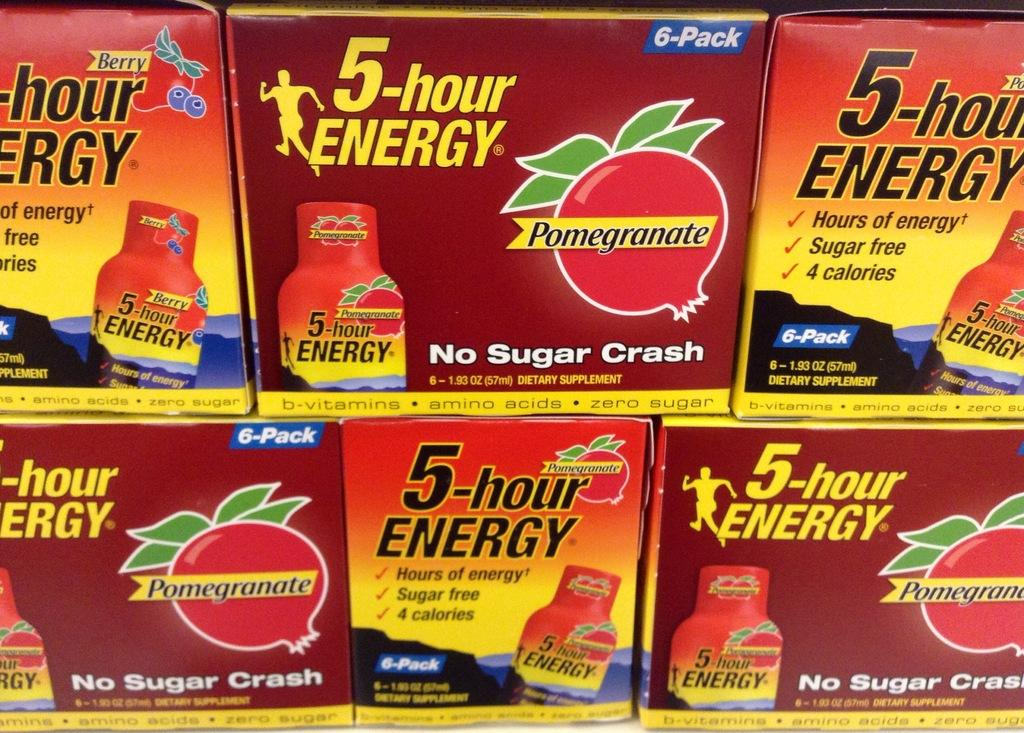Provide a one-sentence caption for the provided image. Six boxes of 5 hour Energy with three of them haing Pomegranate flavoring to it and No Sugar Crash written on the box. 